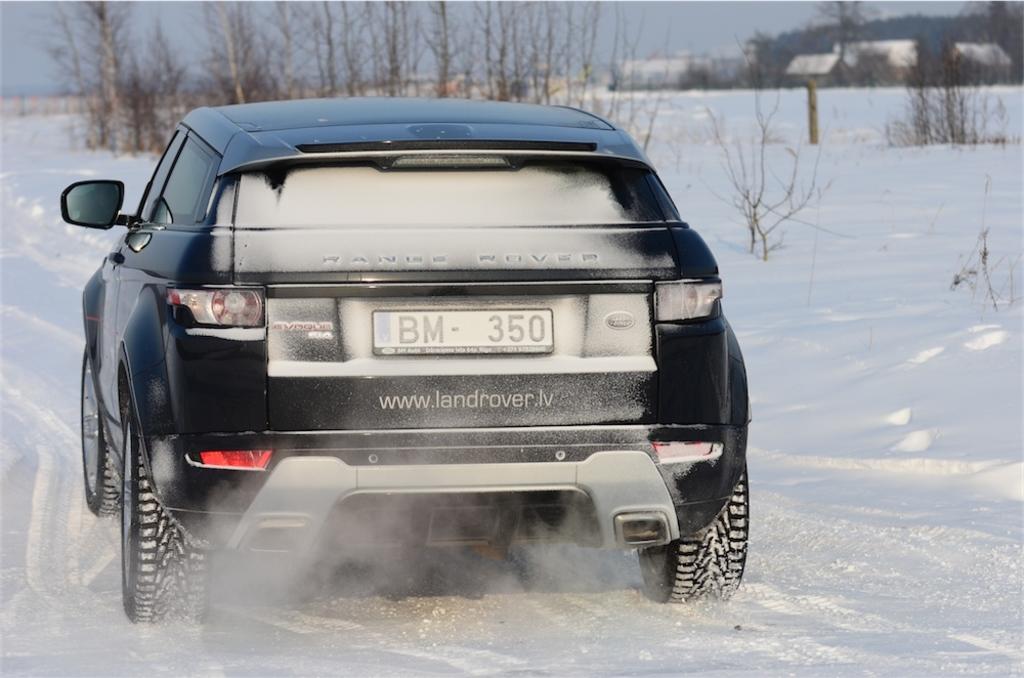What does the license plate say?
Your response must be concise. Bm 350. What is the tag number?
Ensure brevity in your answer.  Bm 350. 